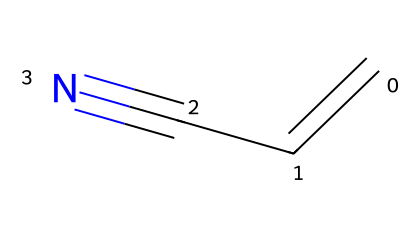What is the molecular formula of acrylonitrile? To derive the molecular formula, count the number of each type of atom in the SMILES representation (C=CC#N). There are 3 carbon atoms, 3 hydrogen atoms, and 1 nitrogen atom, giving the formula C3H3N.
Answer: C3H3N How many carbon atoms are present in acrylonitrile? From the SMILES representation (C=CC#N), there are 3 carbon atoms represented by 'C'.
Answer: 3 What functional group is present in acrylonitrile? The SMILES indicates a nitrile group (-C#N), which is characterized by a carbon triple-bonded to a nitrogen atom, indicating it is a nitrile.
Answer: nitrile How many π bonds are in acrylonitrile? The structure shows a double bond between the first two carbon atoms and a triple bond between the last carbon and nitrogen. Thus, there are 2 π bonds (1 from the double bond and 1 from the triple bond).
Answer: 2 What type of reaction can acrylonitrile undergo in polymerization? Acrylonitrile can undergo addition polymerization due to the presence of the double bond (C=C), which allows it to link up into long chains.
Answer: addition polymerization What is the significance of the nitrile group in acrylonitrile? The nitrile group (-C#N) is crucial as it imparts polarity and solubility properties, enhancing acrylonitrile's use in various chemical applications, including plastics.
Answer: polarity and solubility 